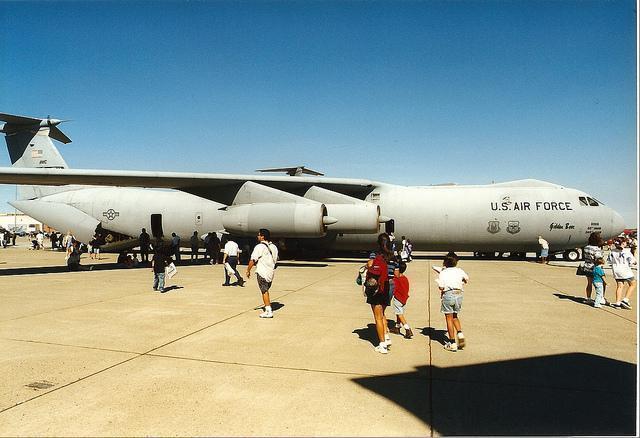What type of military individual fly's this plane?
Indicate the correct choice and explain in the format: 'Answer: answer
Rationale: rationale.'
Options: Marine, airmen, seaman, soldier. Answer: airmen.
Rationale: The airmen would fly the plane. 